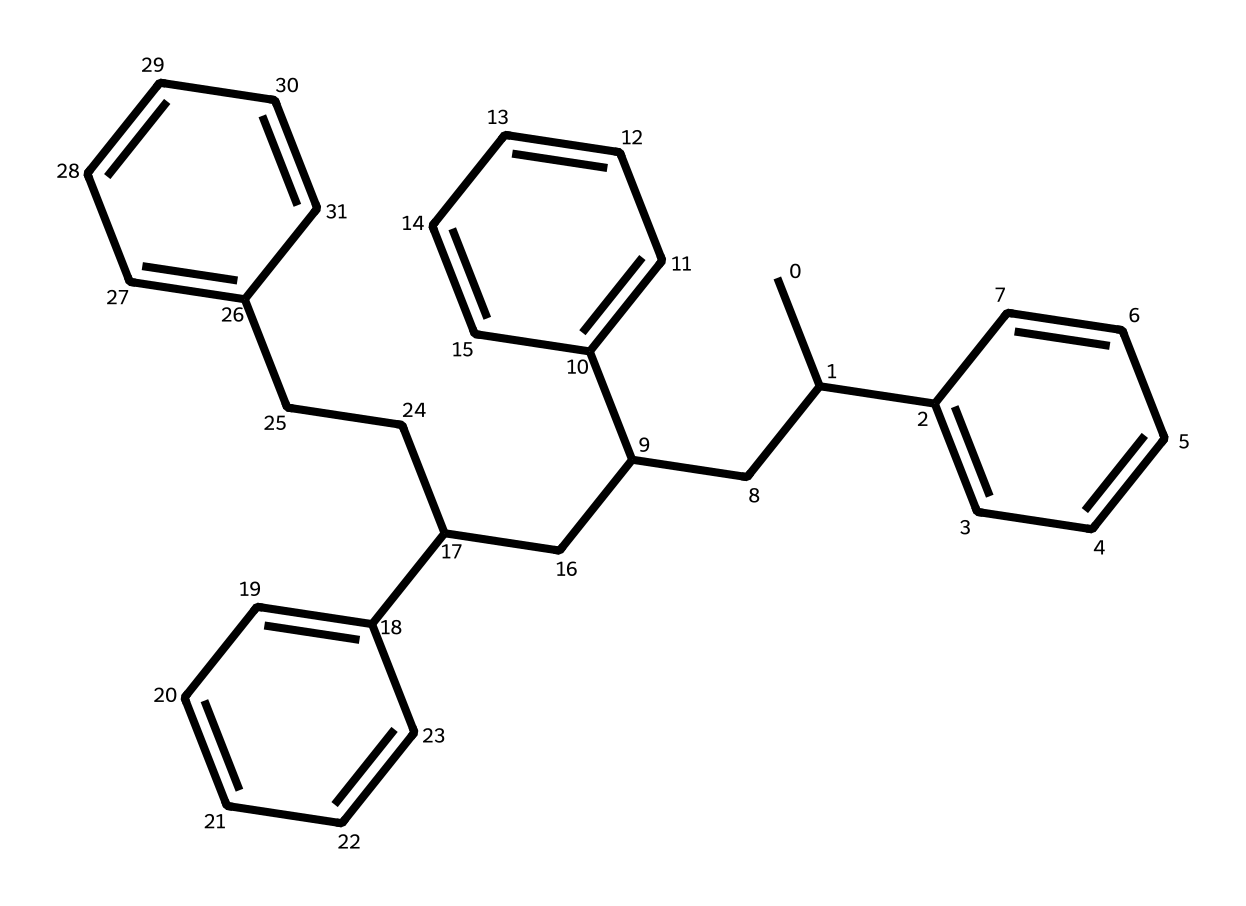How many carbon atoms are present in this structure? By examining the SMILES representation, we can count each carbon atom. Each "C" represents a carbon atom, and we can see there are 16 instances of "C" in the SMILES string.
Answer: 16 What type of polymer is represented by this structure? The presence of repeating units of styrene indicates that this is a polystyrene polymer, which is formed from polymerizing the monomer styrene.
Answer: polystyrene What type of bonding is primarily present in this molecule? The structure shows carbon-carbon single and double bonds as part of the carbon chain and aromatic rings, therefore it consists primarily of covalent bonds.
Answer: covalent How many benzene rings are present in this structure? Upon analyzing the structure, we can identify four distinct occurrences of the aromatic ring, indicated by the "(C=C)" and the cyclic nature of the carbon arrangement.
Answer: 4 What is the degree of unsaturation in this molecule? The degree of unsaturation can be calculated by counting the number of rings and double bonds. There are four rings and double bonds present, contributing 4 degrees of unsaturation.
Answer: 4 